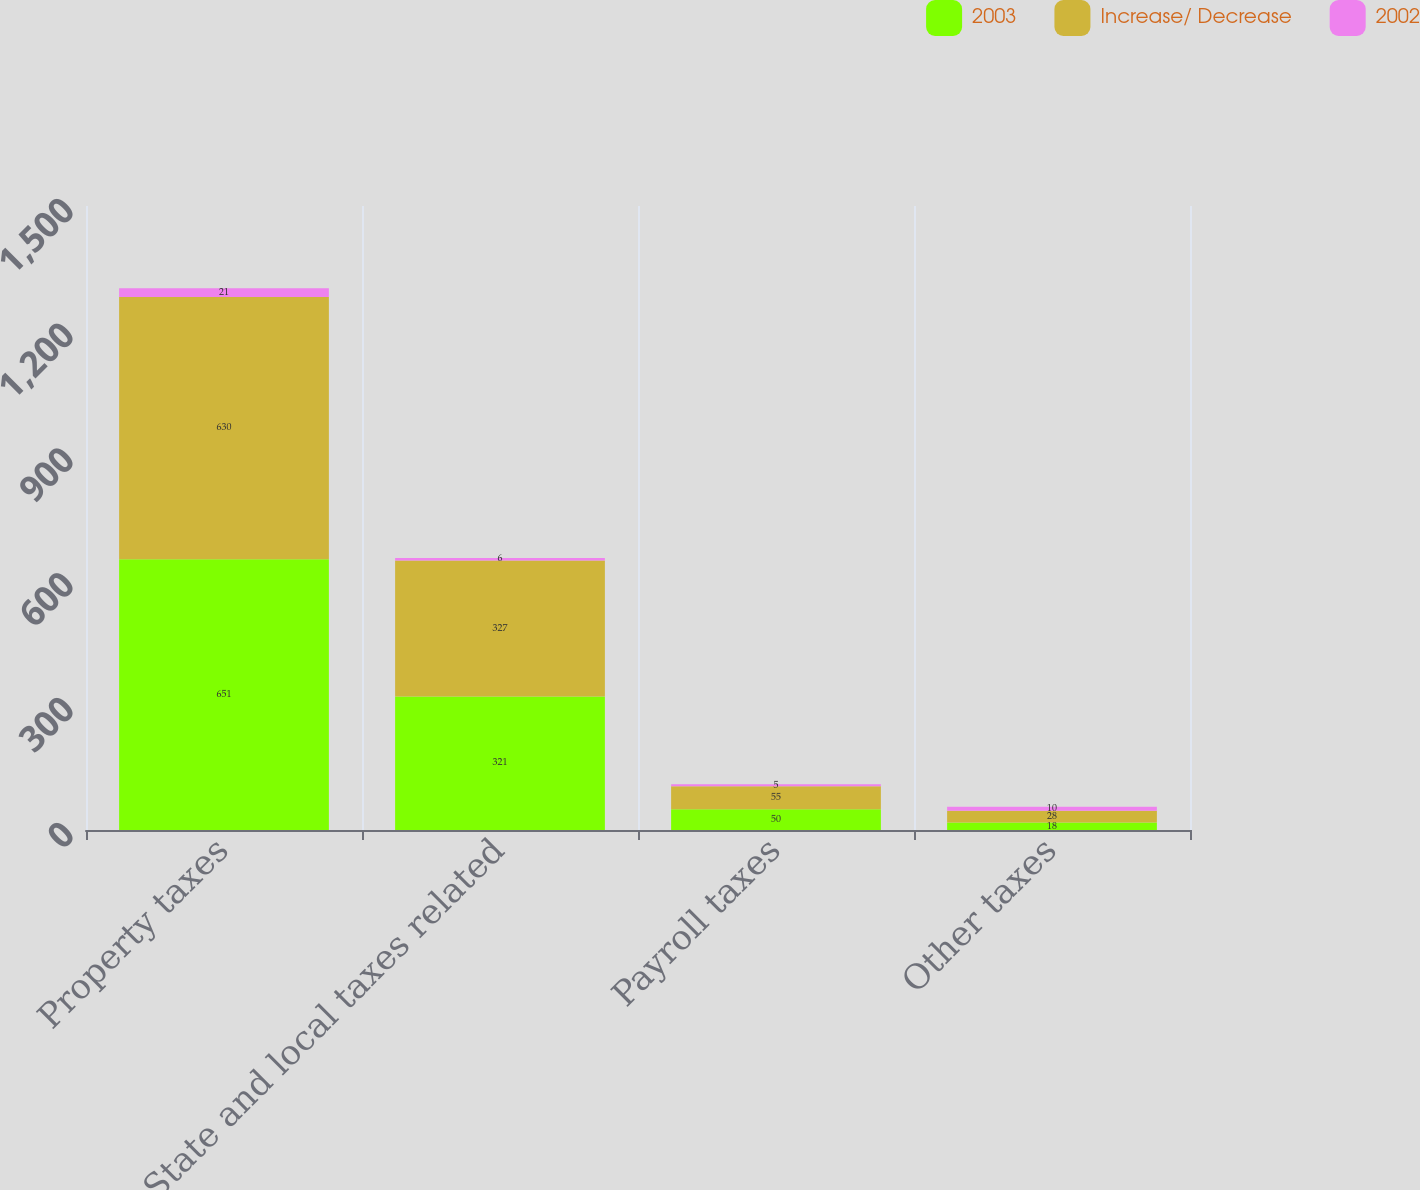<chart> <loc_0><loc_0><loc_500><loc_500><stacked_bar_chart><ecel><fcel>Property taxes<fcel>State and local taxes related<fcel>Payroll taxes<fcel>Other taxes<nl><fcel>2003<fcel>651<fcel>321<fcel>50<fcel>18<nl><fcel>Increase/ Decrease<fcel>630<fcel>327<fcel>55<fcel>28<nl><fcel>2002<fcel>21<fcel>6<fcel>5<fcel>10<nl></chart> 